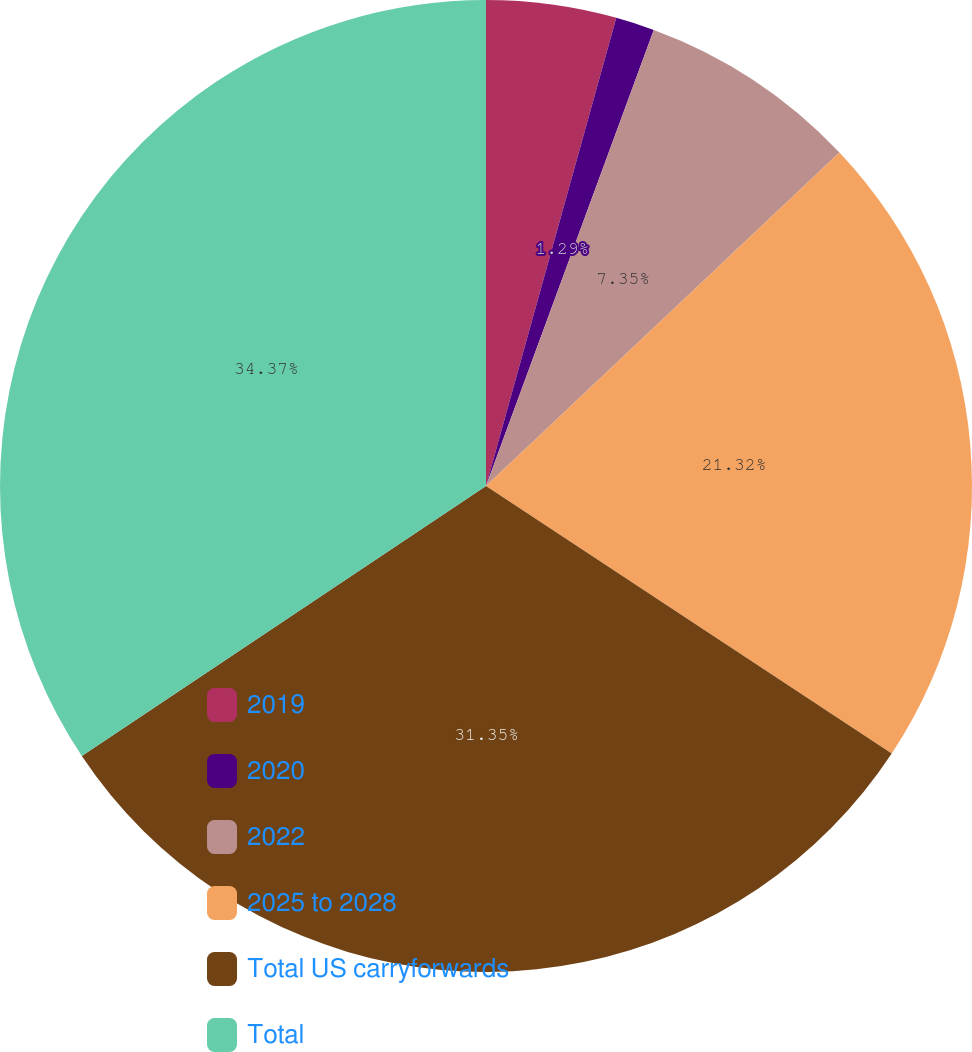<chart> <loc_0><loc_0><loc_500><loc_500><pie_chart><fcel>2019<fcel>2020<fcel>2022<fcel>2025 to 2028<fcel>Total US carryforwards<fcel>Total<nl><fcel>4.32%<fcel>1.29%<fcel>7.35%<fcel>21.32%<fcel>31.35%<fcel>34.37%<nl></chart> 